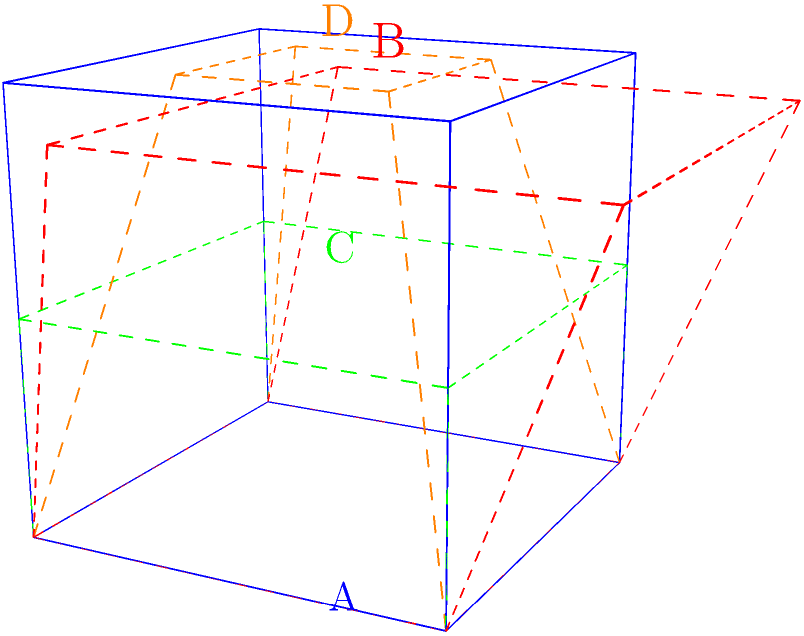As a Starfleet engineer, you are tasked with identifying the correct warp field geometry for a new starship design. Based on the 3D representations shown, which of the labeled warp field geometries (A, B, C, or D) correctly maintains a consistent spatial relationship between the upper and lower planes, ensuring optimal warp field stability? To identify the correct warp field geometry, we need to analyze the spatial relationships between the upper and lower planes of each representation:

1. Geometry A (blue):
   - The upper plane is an exact parallel translation of the lower plane.
   - All vertical edges connecting the planes are parallel and of equal length.
   - This maintains a consistent spatial relationship, crucial for warp field stability.

2. Geometry B (red, dashed):
   - The upper plane is shifted diagonally relative to the lower plane.
   - Vertical edges are not parallel, creating an inconsistent field shape.
   - This would lead to warp field instability and inefficiency.

3. Geometry C (green, dashed):
   - The upper plane is closer to the lower plane compared to other geometries.
   - While maintaining parallelism, the reduced distance between planes would limit warp field strength.
   - This configuration would not be optimal for high-warp operations.

4. Geometry D (orange, dashed):
   - The upper plane is smaller than the lower plane, creating a tapered shape.
   - This non-uniform geometry would result in an uneven warp field distribution.
   - Such a configuration would lead to subspace distortions and potential structural stress on the ship.

Based on established warp field theory in Star Trek, the ideal warp field geometry should maintain a consistent shape and spatial relationship to ensure stability and efficiency. Geometry A satisfies these requirements by preserving parallel planes with consistent spacing, which is crucial for maintaining a stable warp bubble around the ship.
Answer: A 